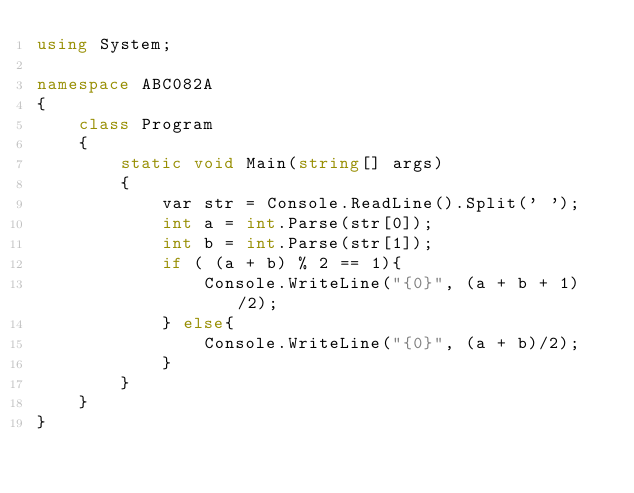Convert code to text. <code><loc_0><loc_0><loc_500><loc_500><_C#_>using System;

namespace ABC082A
{
    class Program
    {
        static void Main(string[] args)
        {
            var str = Console.ReadLine().Split(' ');
            int a = int.Parse(str[0]);
            int b = int.Parse(str[1]);
            if ( (a + b) % 2 == 1){
                Console.WriteLine("{0}", (a + b + 1)/2);
            } else{
                Console.WriteLine("{0}", (a + b)/2);
            }
        }
    }
}
</code> 